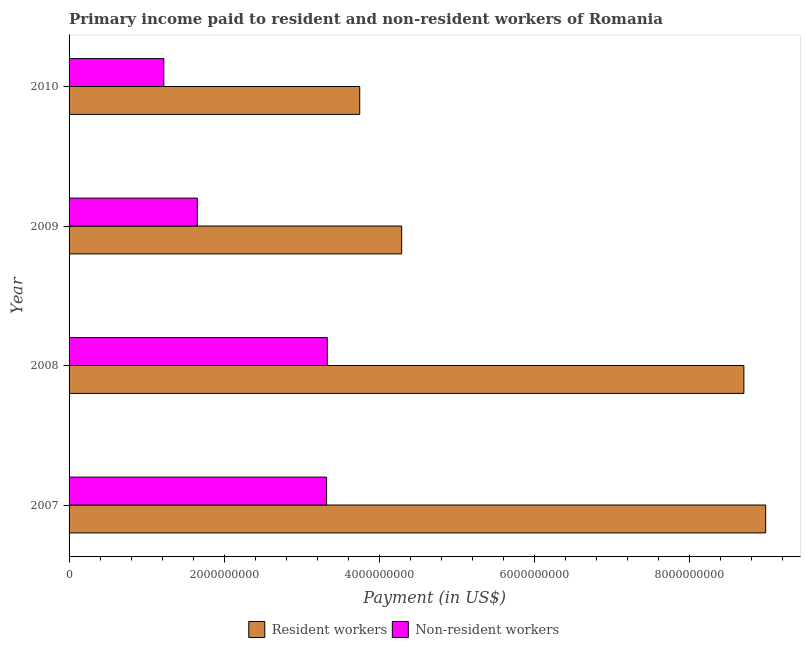Are the number of bars on each tick of the Y-axis equal?
Give a very brief answer. Yes. How many bars are there on the 3rd tick from the top?
Keep it short and to the point. 2. How many bars are there on the 3rd tick from the bottom?
Your response must be concise. 2. What is the label of the 1st group of bars from the top?
Give a very brief answer. 2010. In how many cases, is the number of bars for a given year not equal to the number of legend labels?
Give a very brief answer. 0. What is the payment made to non-resident workers in 2010?
Give a very brief answer. 1.22e+09. Across all years, what is the maximum payment made to resident workers?
Your answer should be very brief. 8.98e+09. Across all years, what is the minimum payment made to non-resident workers?
Offer a very short reply. 1.22e+09. In which year was the payment made to non-resident workers minimum?
Offer a terse response. 2010. What is the total payment made to non-resident workers in the graph?
Give a very brief answer. 9.53e+09. What is the difference between the payment made to resident workers in 2009 and that in 2010?
Offer a terse response. 5.41e+08. What is the difference between the payment made to resident workers in 2009 and the payment made to non-resident workers in 2010?
Offer a terse response. 3.07e+09. What is the average payment made to resident workers per year?
Your answer should be compact. 6.43e+09. In the year 2009, what is the difference between the payment made to non-resident workers and payment made to resident workers?
Offer a very short reply. -2.64e+09. In how many years, is the payment made to non-resident workers greater than 7600000000 US$?
Ensure brevity in your answer.  0. What is the ratio of the payment made to resident workers in 2008 to that in 2010?
Your answer should be compact. 2.32. Is the difference between the payment made to resident workers in 2008 and 2009 greater than the difference between the payment made to non-resident workers in 2008 and 2009?
Keep it short and to the point. Yes. What is the difference between the highest and the second highest payment made to non-resident workers?
Offer a terse response. 9.00e+06. What is the difference between the highest and the lowest payment made to non-resident workers?
Your response must be concise. 2.11e+09. Is the sum of the payment made to resident workers in 2009 and 2010 greater than the maximum payment made to non-resident workers across all years?
Ensure brevity in your answer.  Yes. What does the 1st bar from the top in 2009 represents?
Provide a succinct answer. Non-resident workers. What does the 2nd bar from the bottom in 2009 represents?
Your response must be concise. Non-resident workers. How many bars are there?
Ensure brevity in your answer.  8. Are all the bars in the graph horizontal?
Ensure brevity in your answer.  Yes. How many years are there in the graph?
Provide a succinct answer. 4. What is the difference between two consecutive major ticks on the X-axis?
Ensure brevity in your answer.  2.00e+09. Does the graph contain any zero values?
Keep it short and to the point. No. Where does the legend appear in the graph?
Make the answer very short. Bottom center. How are the legend labels stacked?
Your answer should be very brief. Horizontal. What is the title of the graph?
Offer a terse response. Primary income paid to resident and non-resident workers of Romania. Does "Residents" appear as one of the legend labels in the graph?
Your answer should be very brief. No. What is the label or title of the X-axis?
Keep it short and to the point. Payment (in US$). What is the Payment (in US$) of Resident workers in 2007?
Give a very brief answer. 8.98e+09. What is the Payment (in US$) of Non-resident workers in 2007?
Provide a succinct answer. 3.32e+09. What is the Payment (in US$) in Resident workers in 2008?
Ensure brevity in your answer.  8.70e+09. What is the Payment (in US$) of Non-resident workers in 2008?
Ensure brevity in your answer.  3.33e+09. What is the Payment (in US$) in Resident workers in 2009?
Offer a very short reply. 4.29e+09. What is the Payment (in US$) in Non-resident workers in 2009?
Offer a very short reply. 1.65e+09. What is the Payment (in US$) of Resident workers in 2010?
Your response must be concise. 3.75e+09. What is the Payment (in US$) in Non-resident workers in 2010?
Ensure brevity in your answer.  1.22e+09. Across all years, what is the maximum Payment (in US$) in Resident workers?
Keep it short and to the point. 8.98e+09. Across all years, what is the maximum Payment (in US$) in Non-resident workers?
Offer a very short reply. 3.33e+09. Across all years, what is the minimum Payment (in US$) in Resident workers?
Keep it short and to the point. 3.75e+09. Across all years, what is the minimum Payment (in US$) in Non-resident workers?
Offer a very short reply. 1.22e+09. What is the total Payment (in US$) of Resident workers in the graph?
Your answer should be compact. 2.57e+1. What is the total Payment (in US$) in Non-resident workers in the graph?
Provide a short and direct response. 9.53e+09. What is the difference between the Payment (in US$) in Resident workers in 2007 and that in 2008?
Provide a short and direct response. 2.81e+08. What is the difference between the Payment (in US$) of Non-resident workers in 2007 and that in 2008?
Give a very brief answer. -9.00e+06. What is the difference between the Payment (in US$) of Resident workers in 2007 and that in 2009?
Give a very brief answer. 4.69e+09. What is the difference between the Payment (in US$) of Non-resident workers in 2007 and that in 2009?
Your answer should be very brief. 1.67e+09. What is the difference between the Payment (in US$) of Resident workers in 2007 and that in 2010?
Ensure brevity in your answer.  5.24e+09. What is the difference between the Payment (in US$) of Non-resident workers in 2007 and that in 2010?
Make the answer very short. 2.10e+09. What is the difference between the Payment (in US$) in Resident workers in 2008 and that in 2009?
Provide a short and direct response. 4.41e+09. What is the difference between the Payment (in US$) in Non-resident workers in 2008 and that in 2009?
Ensure brevity in your answer.  1.68e+09. What is the difference between the Payment (in US$) of Resident workers in 2008 and that in 2010?
Provide a succinct answer. 4.95e+09. What is the difference between the Payment (in US$) of Non-resident workers in 2008 and that in 2010?
Provide a succinct answer. 2.11e+09. What is the difference between the Payment (in US$) in Resident workers in 2009 and that in 2010?
Your answer should be compact. 5.41e+08. What is the difference between the Payment (in US$) of Non-resident workers in 2009 and that in 2010?
Keep it short and to the point. 4.32e+08. What is the difference between the Payment (in US$) in Resident workers in 2007 and the Payment (in US$) in Non-resident workers in 2008?
Offer a very short reply. 5.65e+09. What is the difference between the Payment (in US$) in Resident workers in 2007 and the Payment (in US$) in Non-resident workers in 2009?
Keep it short and to the point. 7.33e+09. What is the difference between the Payment (in US$) of Resident workers in 2007 and the Payment (in US$) of Non-resident workers in 2010?
Ensure brevity in your answer.  7.76e+09. What is the difference between the Payment (in US$) of Resident workers in 2008 and the Payment (in US$) of Non-resident workers in 2009?
Provide a succinct answer. 7.05e+09. What is the difference between the Payment (in US$) of Resident workers in 2008 and the Payment (in US$) of Non-resident workers in 2010?
Your answer should be very brief. 7.48e+09. What is the difference between the Payment (in US$) of Resident workers in 2009 and the Payment (in US$) of Non-resident workers in 2010?
Your answer should be compact. 3.07e+09. What is the average Payment (in US$) in Resident workers per year?
Make the answer very short. 6.43e+09. What is the average Payment (in US$) in Non-resident workers per year?
Give a very brief answer. 2.38e+09. In the year 2007, what is the difference between the Payment (in US$) of Resident workers and Payment (in US$) of Non-resident workers?
Keep it short and to the point. 5.66e+09. In the year 2008, what is the difference between the Payment (in US$) of Resident workers and Payment (in US$) of Non-resident workers?
Ensure brevity in your answer.  5.37e+09. In the year 2009, what is the difference between the Payment (in US$) of Resident workers and Payment (in US$) of Non-resident workers?
Your response must be concise. 2.64e+09. In the year 2010, what is the difference between the Payment (in US$) of Resident workers and Payment (in US$) of Non-resident workers?
Your answer should be very brief. 2.53e+09. What is the ratio of the Payment (in US$) of Resident workers in 2007 to that in 2008?
Provide a short and direct response. 1.03. What is the ratio of the Payment (in US$) of Non-resident workers in 2007 to that in 2008?
Keep it short and to the point. 1. What is the ratio of the Payment (in US$) in Resident workers in 2007 to that in 2009?
Provide a short and direct response. 2.09. What is the ratio of the Payment (in US$) in Non-resident workers in 2007 to that in 2009?
Give a very brief answer. 2.01. What is the ratio of the Payment (in US$) in Resident workers in 2007 to that in 2010?
Offer a terse response. 2.4. What is the ratio of the Payment (in US$) in Non-resident workers in 2007 to that in 2010?
Give a very brief answer. 2.72. What is the ratio of the Payment (in US$) in Resident workers in 2008 to that in 2009?
Your answer should be compact. 2.03. What is the ratio of the Payment (in US$) of Non-resident workers in 2008 to that in 2009?
Your answer should be compact. 2.01. What is the ratio of the Payment (in US$) in Resident workers in 2008 to that in 2010?
Provide a succinct answer. 2.32. What is the ratio of the Payment (in US$) in Non-resident workers in 2008 to that in 2010?
Your answer should be compact. 2.73. What is the ratio of the Payment (in US$) of Resident workers in 2009 to that in 2010?
Make the answer very short. 1.14. What is the ratio of the Payment (in US$) in Non-resident workers in 2009 to that in 2010?
Provide a succinct answer. 1.35. What is the difference between the highest and the second highest Payment (in US$) in Resident workers?
Your answer should be very brief. 2.81e+08. What is the difference between the highest and the second highest Payment (in US$) in Non-resident workers?
Your response must be concise. 9.00e+06. What is the difference between the highest and the lowest Payment (in US$) of Resident workers?
Give a very brief answer. 5.24e+09. What is the difference between the highest and the lowest Payment (in US$) of Non-resident workers?
Keep it short and to the point. 2.11e+09. 